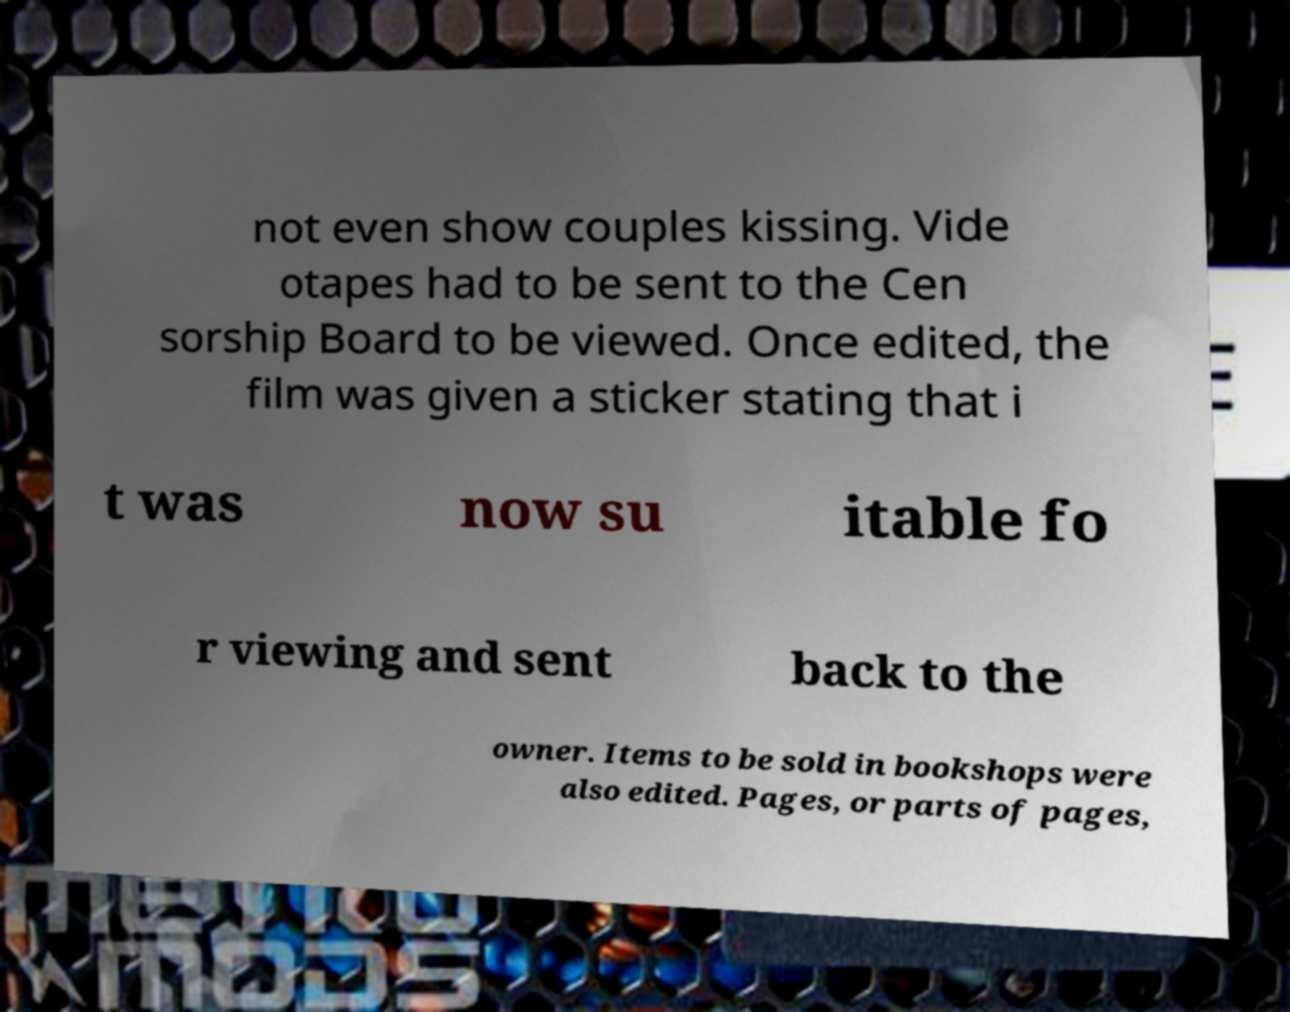Could you extract and type out the text from this image? not even show couples kissing. Vide otapes had to be sent to the Cen sorship Board to be viewed. Once edited, the film was given a sticker stating that i t was now su itable fo r viewing and sent back to the owner. Items to be sold in bookshops were also edited. Pages, or parts of pages, 